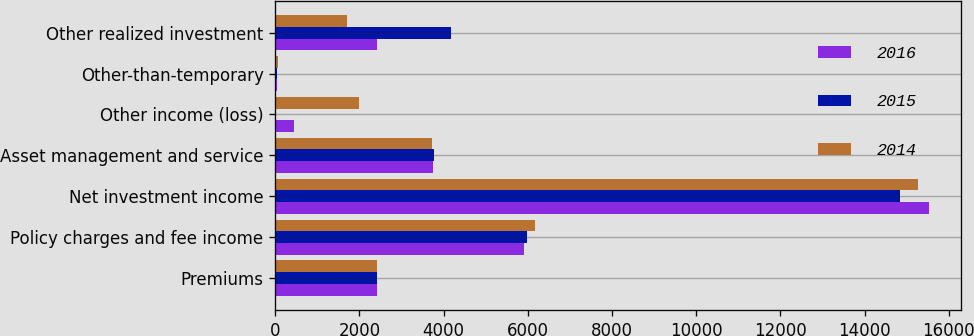Convert chart. <chart><loc_0><loc_0><loc_500><loc_500><stacked_bar_chart><ecel><fcel>Premiums<fcel>Policy charges and fee income<fcel>Net investment income<fcel>Asset management and service<fcel>Other income (loss)<fcel>Other-than-temporary<fcel>Other realized investment<nl><fcel>2016<fcel>2416<fcel>5906<fcel>15520<fcel>3752<fcel>443<fcel>47<fcel>2416<nl><fcel>2015<fcel>2416<fcel>5972<fcel>14829<fcel>3772<fcel>0<fcel>39<fcel>4166<nl><fcel>2014<fcel>2416<fcel>6179<fcel>15256<fcel>3719<fcel>1978<fcel>71<fcel>1692<nl></chart> 